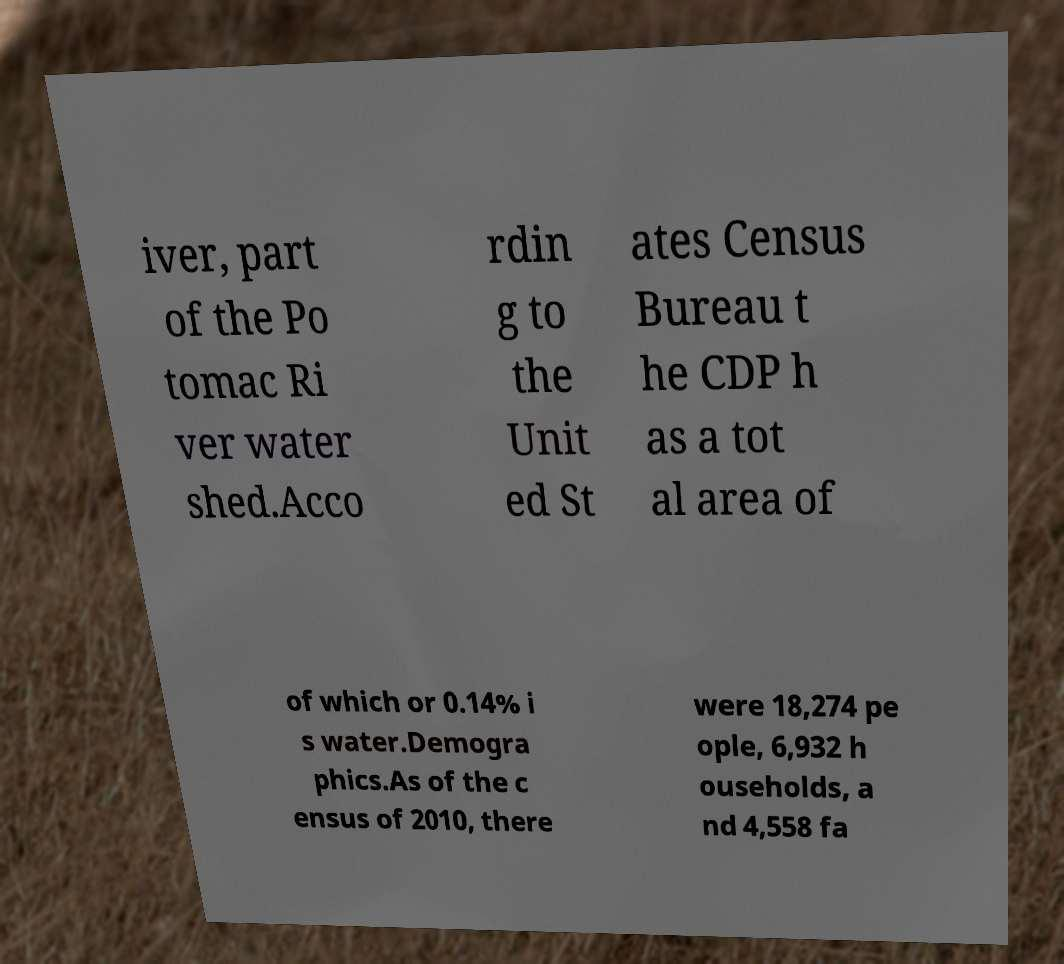For documentation purposes, I need the text within this image transcribed. Could you provide that? iver, part of the Po tomac Ri ver water shed.Acco rdin g to the Unit ed St ates Census Bureau t he CDP h as a tot al area of of which or 0.14% i s water.Demogra phics.As of the c ensus of 2010, there were 18,274 pe ople, 6,932 h ouseholds, a nd 4,558 fa 